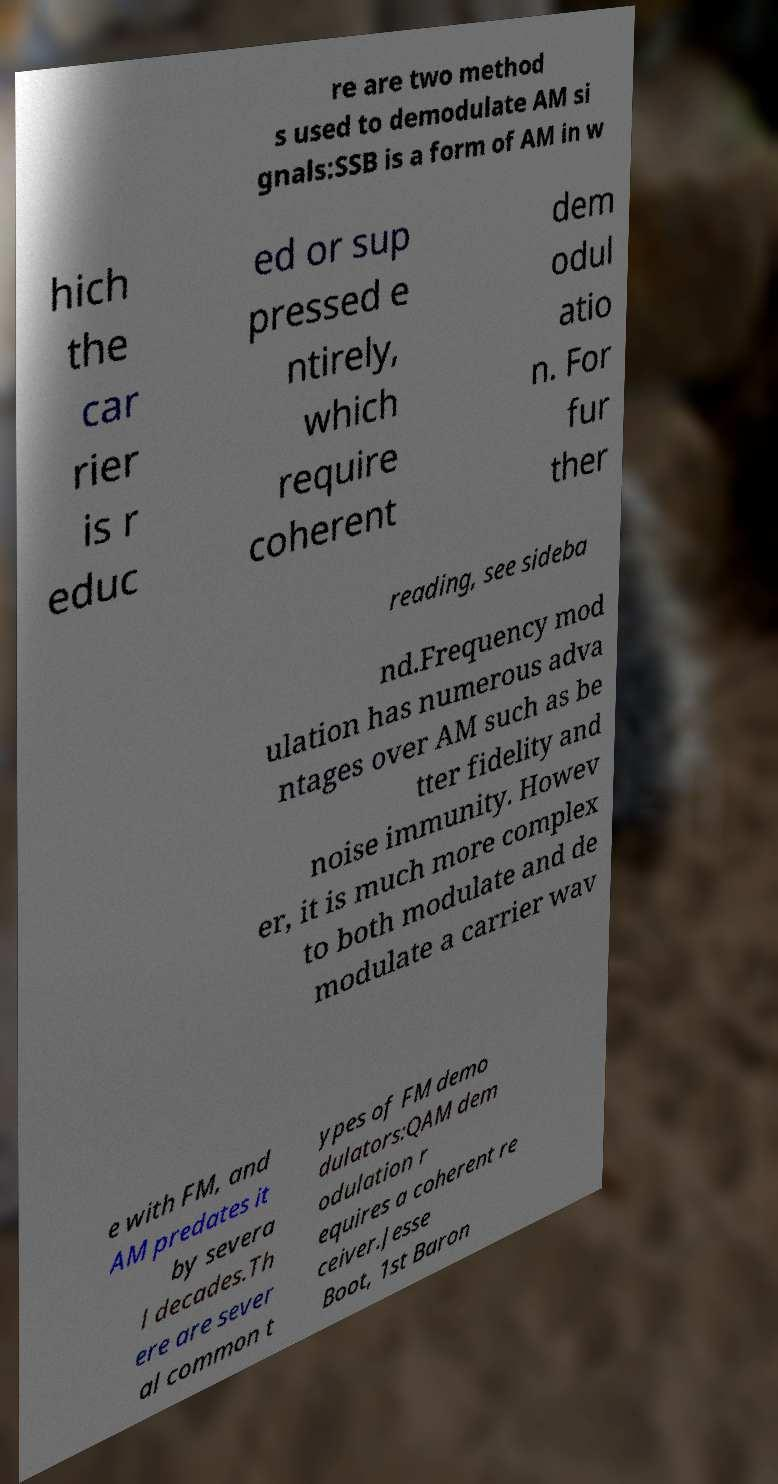Can you read and provide the text displayed in the image?This photo seems to have some interesting text. Can you extract and type it out for me? re are two method s used to demodulate AM si gnals:SSB is a form of AM in w hich the car rier is r educ ed or sup pressed e ntirely, which require coherent dem odul atio n. For fur ther reading, see sideba nd.Frequency mod ulation has numerous adva ntages over AM such as be tter fidelity and noise immunity. Howev er, it is much more complex to both modulate and de modulate a carrier wav e with FM, and AM predates it by severa l decades.Th ere are sever al common t ypes of FM demo dulators:QAM dem odulation r equires a coherent re ceiver.Jesse Boot, 1st Baron 